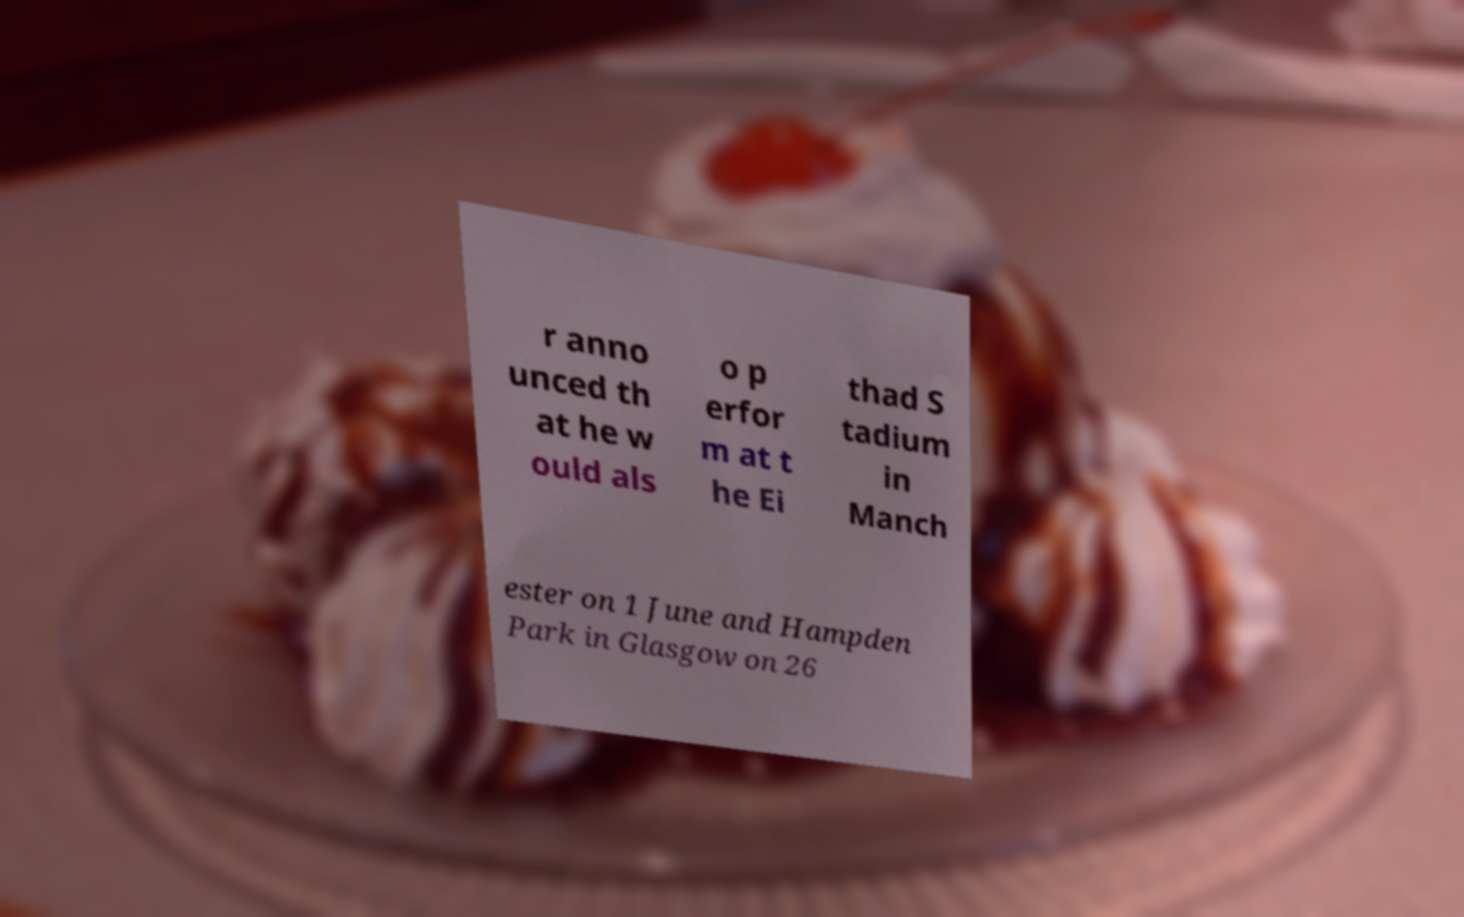There's text embedded in this image that I need extracted. Can you transcribe it verbatim? r anno unced th at he w ould als o p erfor m at t he Ei thad S tadium in Manch ester on 1 June and Hampden Park in Glasgow on 26 